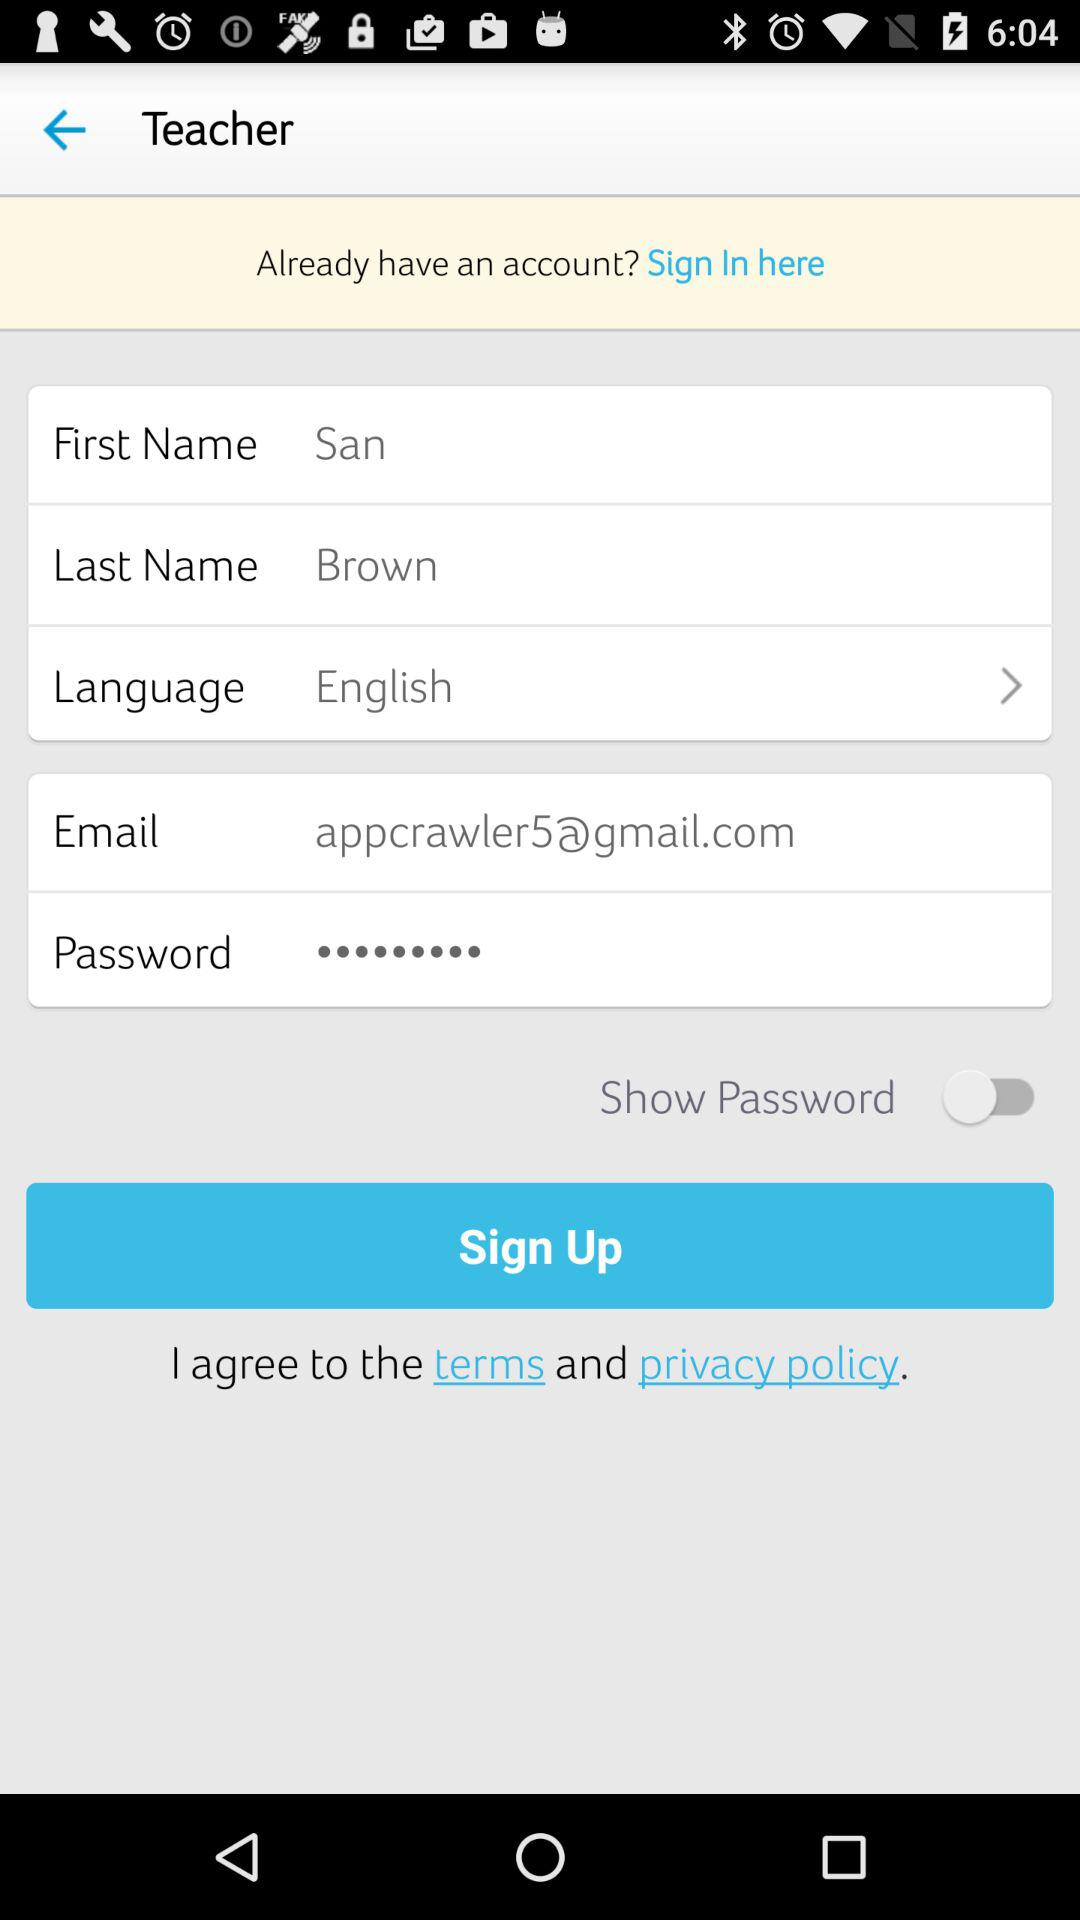What is the given last name? The given last name is Brown. 